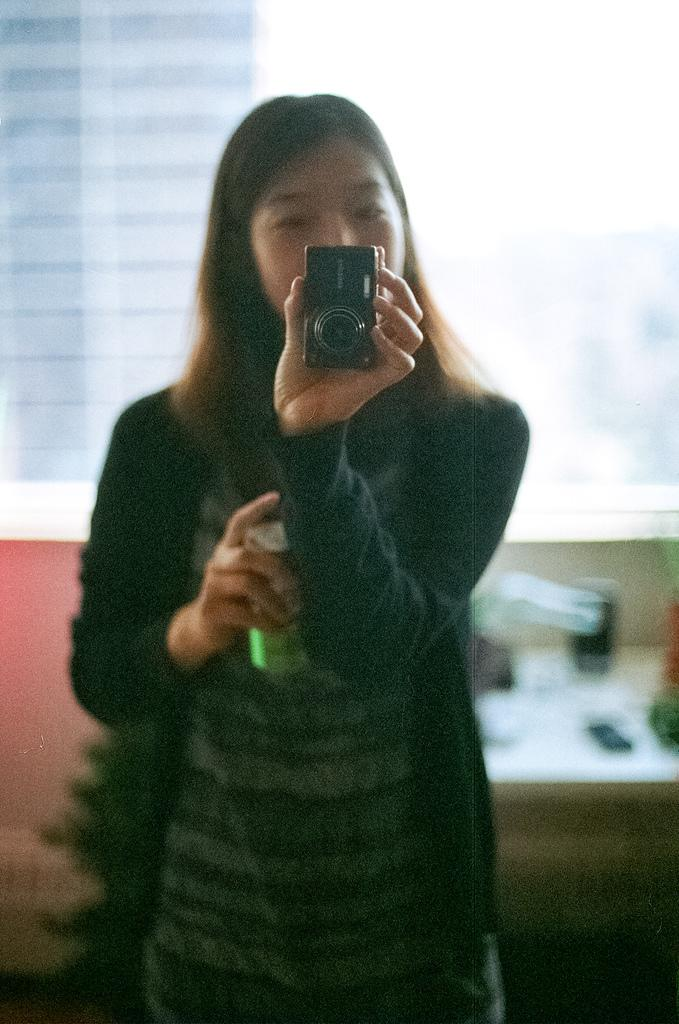What is the main subject of the image? The main subject of the image is a woman. What is the woman holding in her hands? The woman is holding a camera and a can. How many giraffes can be seen in the image? There are no giraffes present in the image. What type of mountain is visible in the background of the image? There is no mountain visible in the image; it only features a woman holding a camera and a can. 